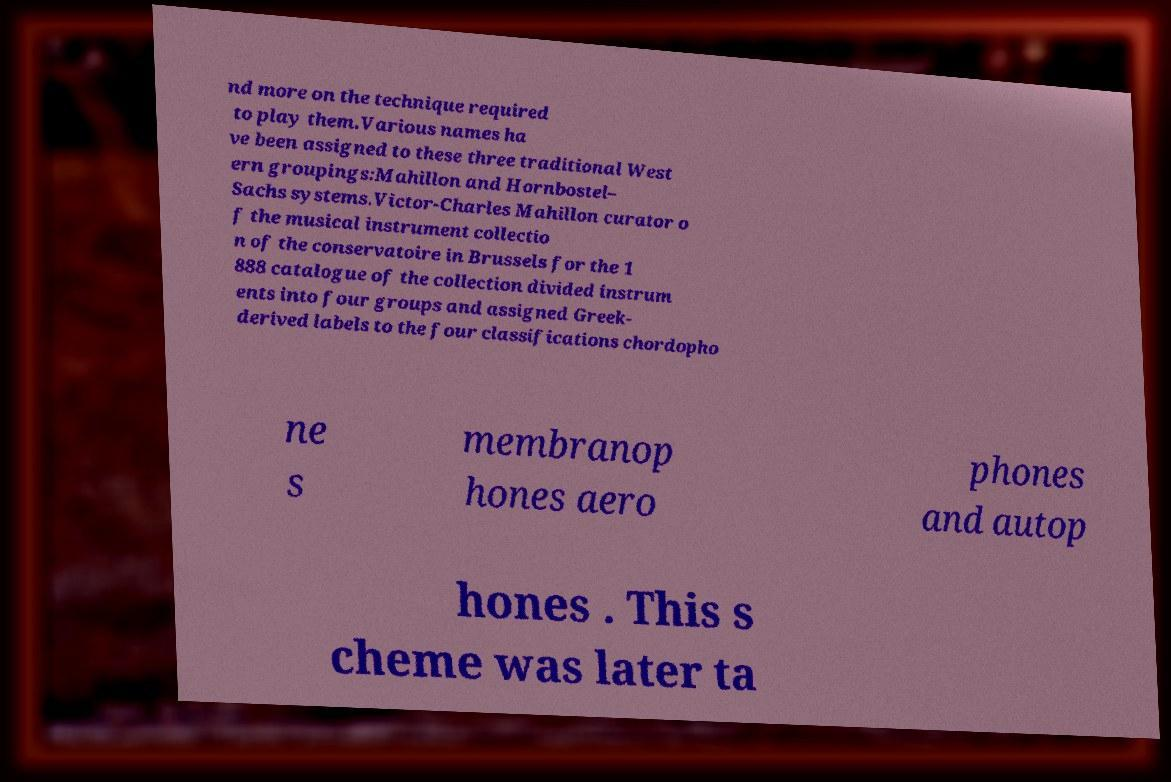Can you read and provide the text displayed in the image?This photo seems to have some interesting text. Can you extract and type it out for me? nd more on the technique required to play them.Various names ha ve been assigned to these three traditional West ern groupings:Mahillon and Hornbostel– Sachs systems.Victor-Charles Mahillon curator o f the musical instrument collectio n of the conservatoire in Brussels for the 1 888 catalogue of the collection divided instrum ents into four groups and assigned Greek- derived labels to the four classifications chordopho ne s membranop hones aero phones and autop hones . This s cheme was later ta 